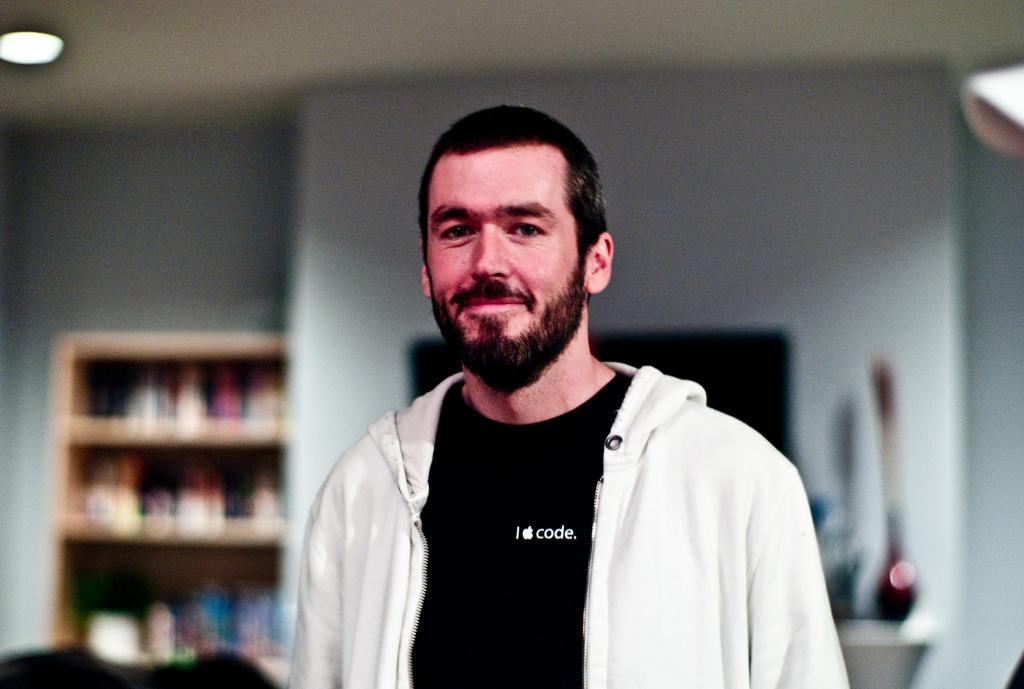<image>
Offer a succinct explanation of the picture presented. A man wearing a black t-shirt that reads, I apple code, stands in a room 